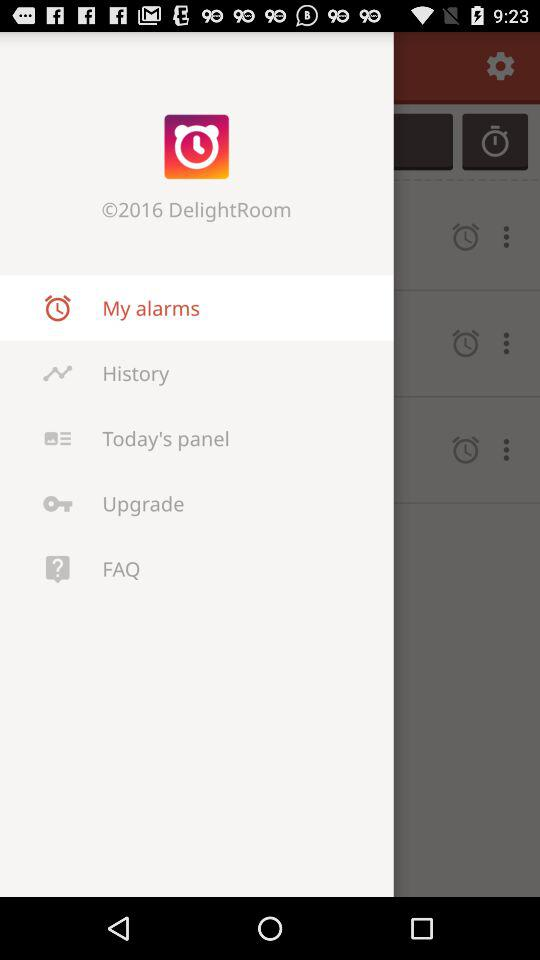What is the name of the application? The name of the application is "Alarmy (Sleep If U Can)". 